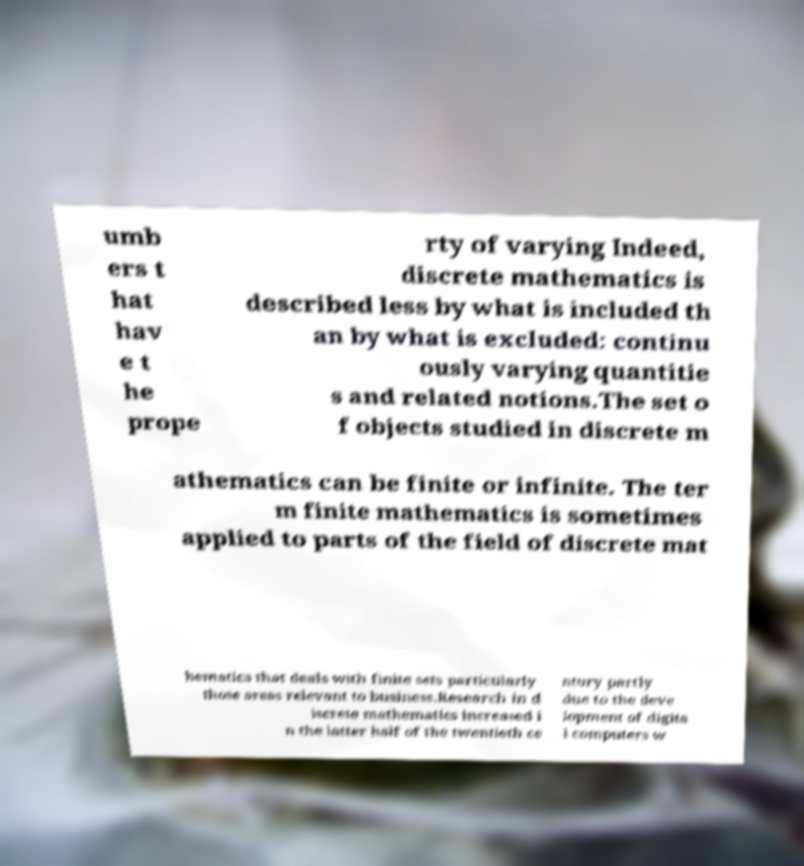There's text embedded in this image that I need extracted. Can you transcribe it verbatim? umb ers t hat hav e t he prope rty of varying Indeed, discrete mathematics is described less by what is included th an by what is excluded: continu ously varying quantitie s and related notions.The set o f objects studied in discrete m athematics can be finite or infinite. The ter m finite mathematics is sometimes applied to parts of the field of discrete mat hematics that deals with finite sets particularly those areas relevant to business.Research in d iscrete mathematics increased i n the latter half of the twentieth ce ntury partly due to the deve lopment of digita l computers w 